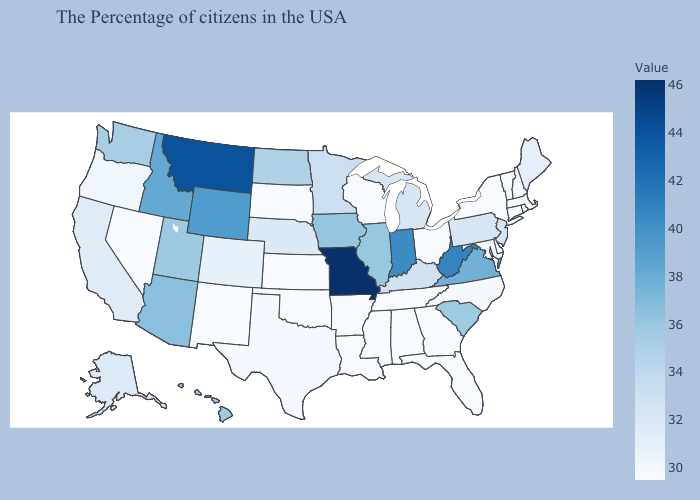Does Utah have a lower value than Indiana?
Answer briefly. Yes. Does Alaska have a higher value than Ohio?
Write a very short answer. Yes. Is the legend a continuous bar?
Keep it brief. Yes. Which states hav the highest value in the Northeast?
Answer briefly. New Jersey. Which states have the highest value in the USA?
Give a very brief answer. Missouri. Among the states that border Minnesota , which have the highest value?
Concise answer only. Iowa. 